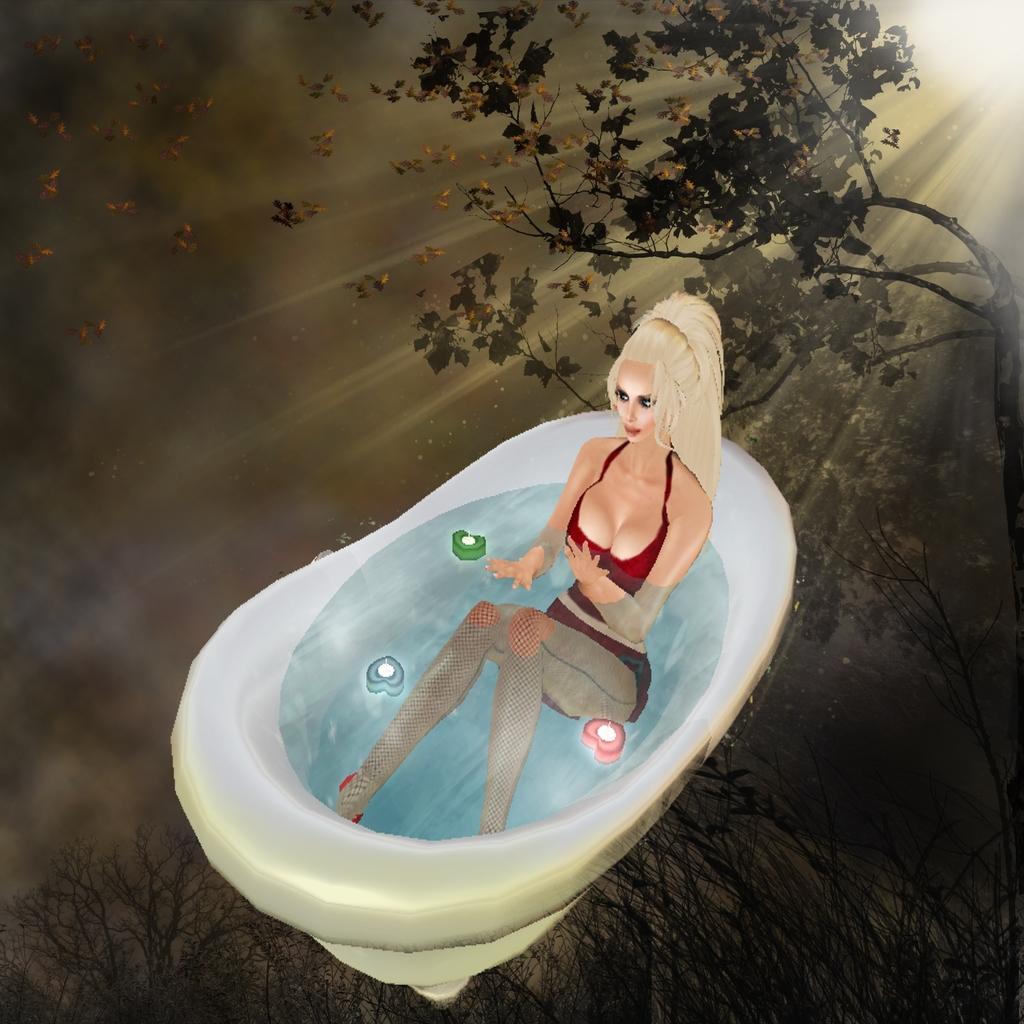Please provide a concise description of this image. This is an animated image. In this image I can see the person sitting in the bathtub. I can see the green, blue and pink color objects in it. In the background I can see the trees, sun and the sky. 